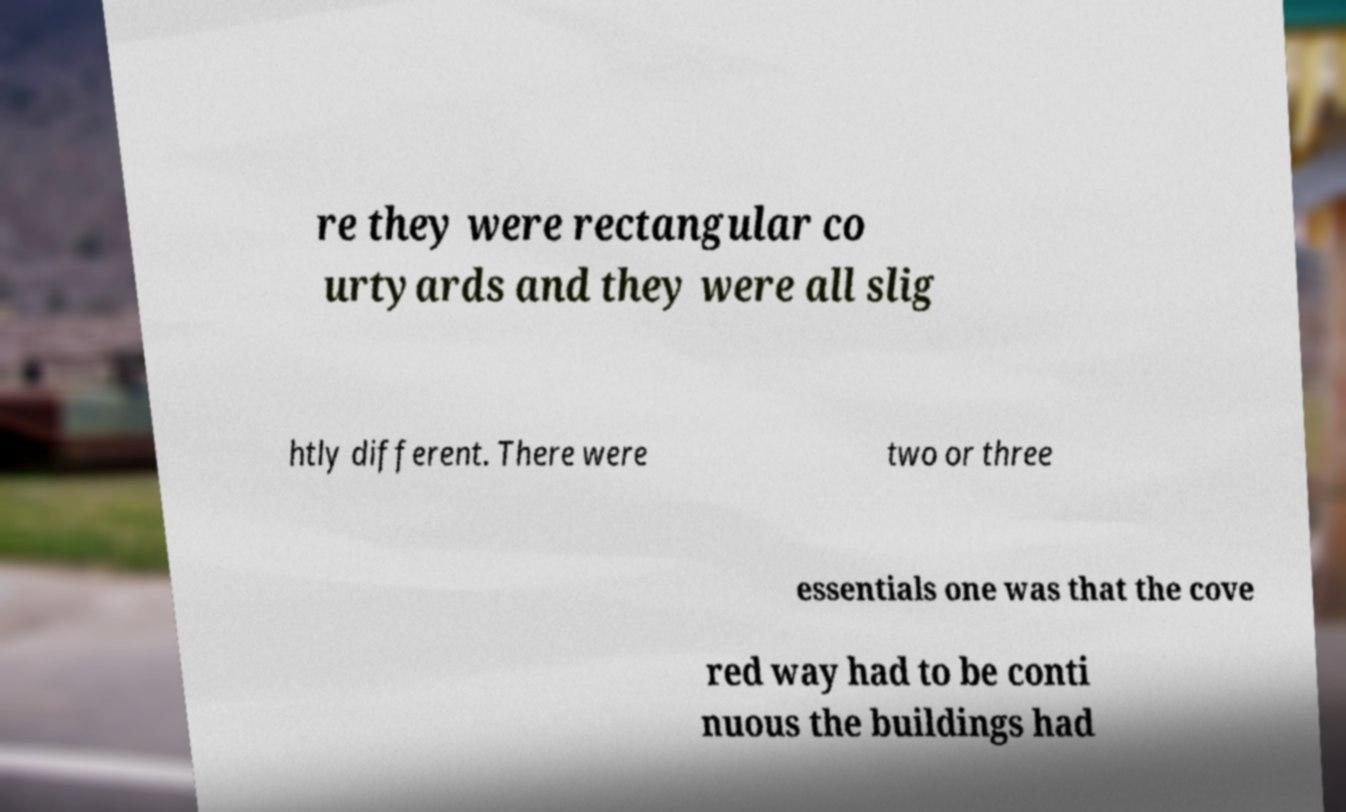Can you accurately transcribe the text from the provided image for me? re they were rectangular co urtyards and they were all slig htly different. There were two or three essentials one was that the cove red way had to be conti nuous the buildings had 